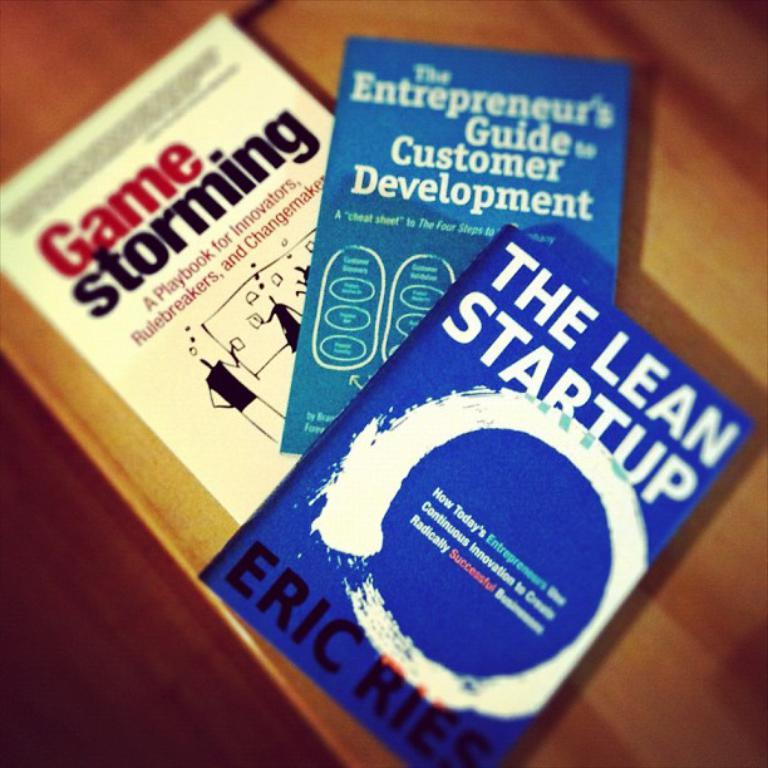<image>
Create a compact narrative representing the image presented. THREE PAPER BACK BOOKS WITH THE TOP ONE WRITTEN BY ERIC RIES 